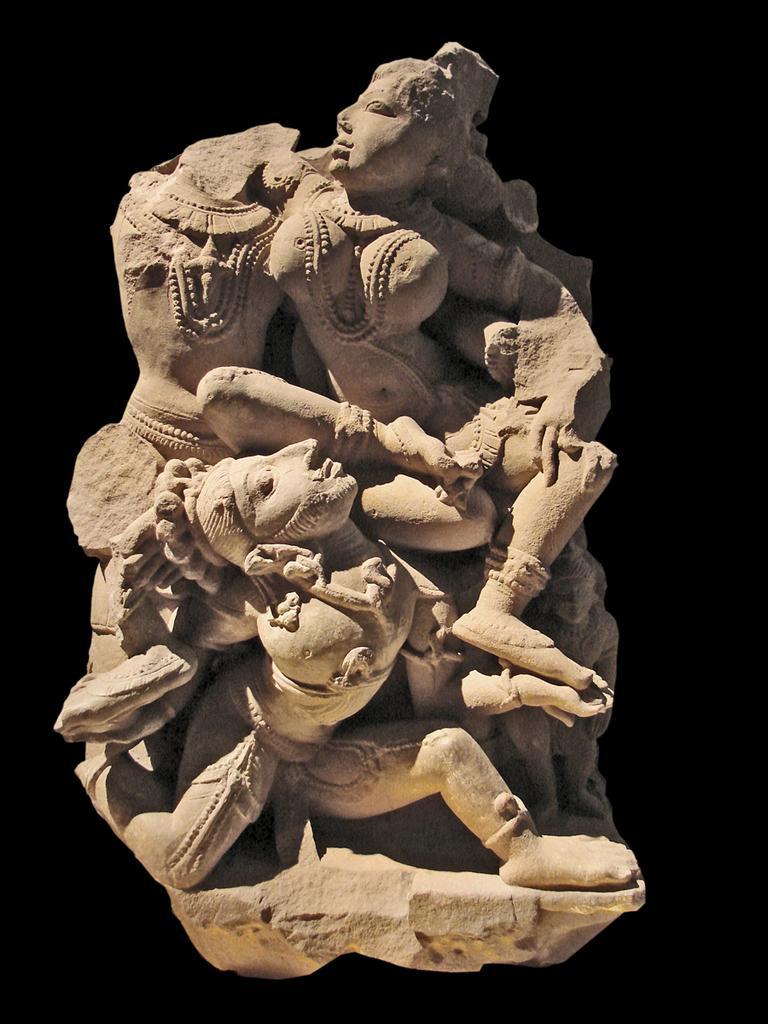Could you give a brief overview of what you see in this image? In the center of the image there is a sculpture. 